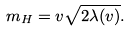<formula> <loc_0><loc_0><loc_500><loc_500>m _ { H } = v \sqrt { 2 \lambda ( v ) } .</formula> 